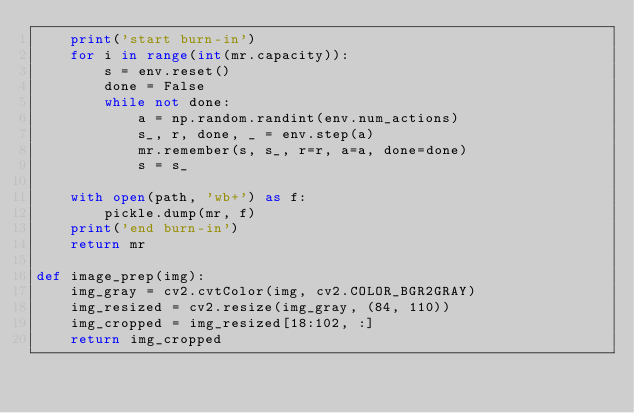<code> <loc_0><loc_0><loc_500><loc_500><_Python_>    print('start burn-in')
    for i in range(int(mr.capacity)):
        s = env.reset()
        done = False
        while not done:
            a = np.random.randint(env.num_actions)
            s_, r, done, _ = env.step(a)
            mr.remember(s, s_, r=r, a=a, done=done)
            s = s_

    with open(path, 'wb+') as f:
        pickle.dump(mr, f)
    print('end burn-in')
    return mr

def image_prep(img):
    img_gray = cv2.cvtColor(img, cv2.COLOR_BGR2GRAY)
    img_resized = cv2.resize(img_gray, (84, 110))
    img_cropped = img_resized[18:102, :]
    return img_cropped</code> 